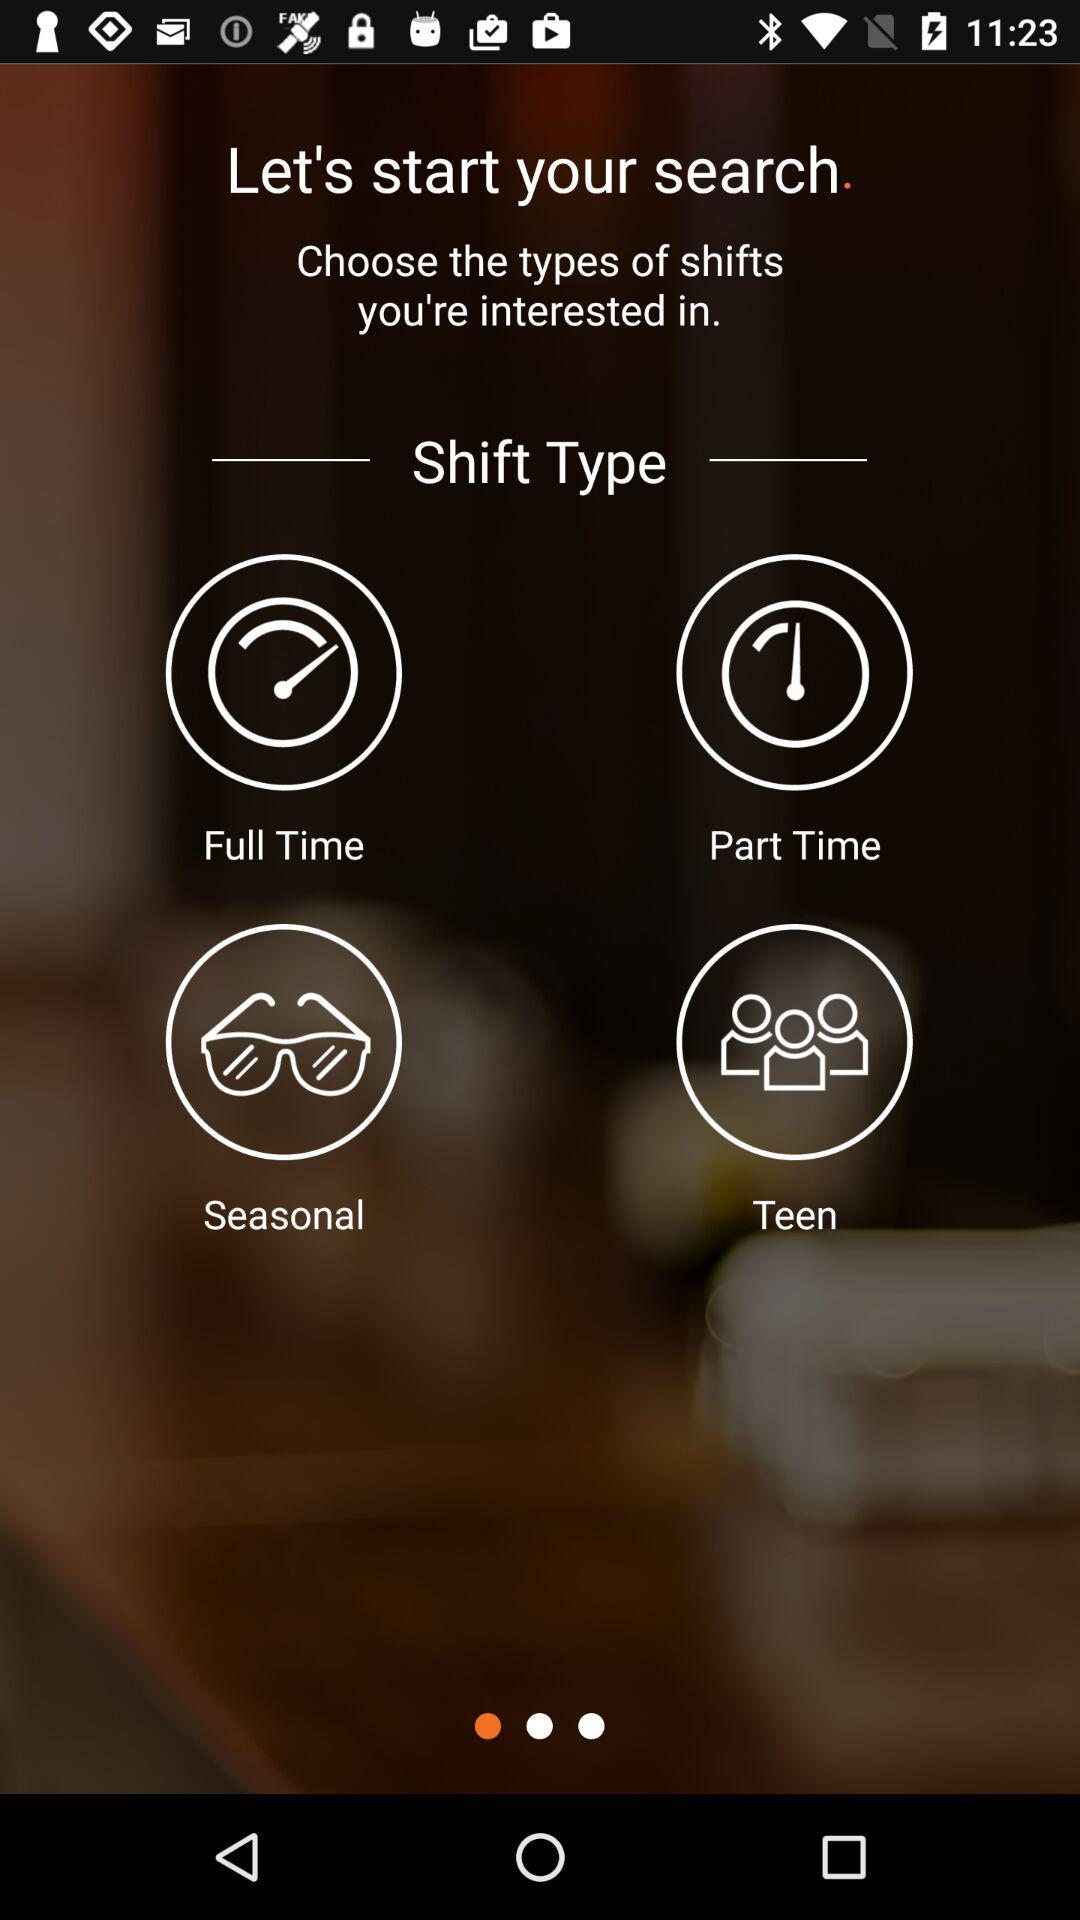How many options are there for the shift type?
Answer the question using a single word or phrase. 4 